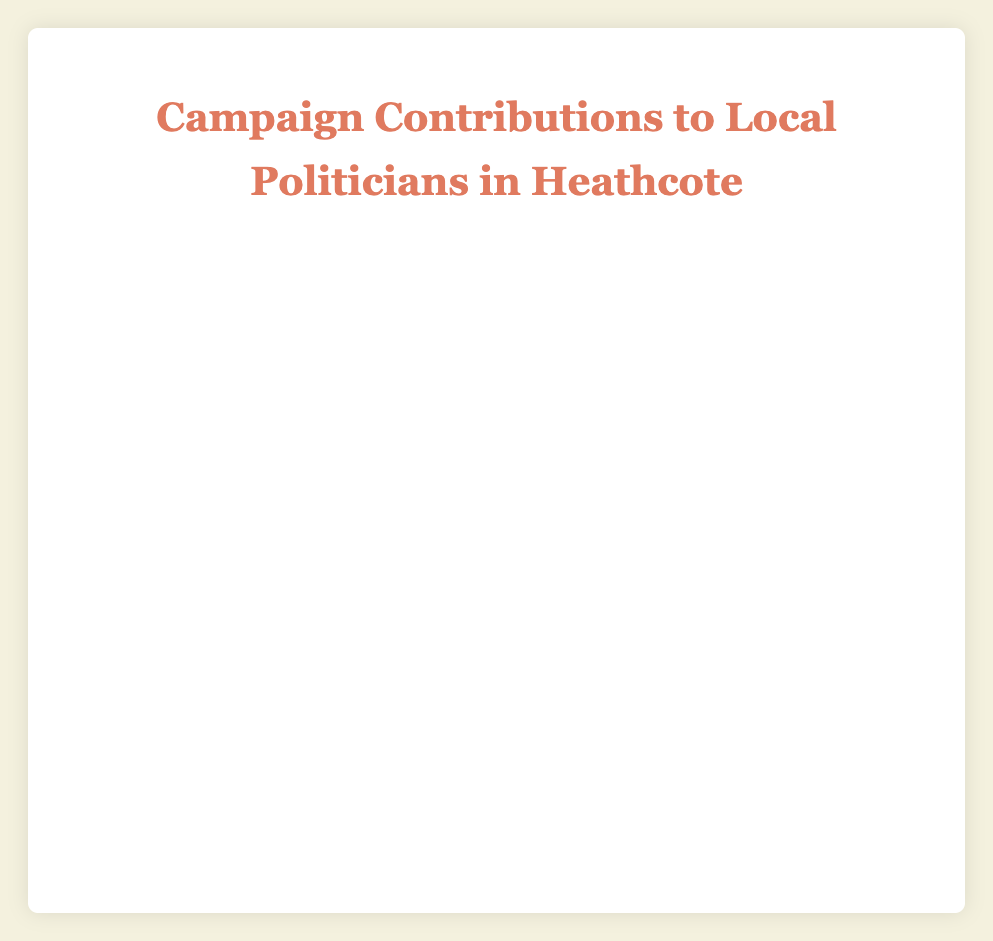Which politician received the highest total campaign contributions in the 2020 election cycle? From the chart, adding up the contributions from Individual, PAC, and Corporate Donations for each politician in 2020: Jane Doe: 22000 + 7000 + 3000 = 32000; John Smith: 20000 + 8000 + 4000 = 32000; Alice Johnson: 14000 + 4000 + 2000 = 20000; Robert Brown: 12000 + 5000 + 1500 = 18500. Jane Doe and John Smith both received the highest total contributions of 32000.
Answer: Jane Doe and John Smith Which election cycle had more Individual Donations for Jane Doe? Refer to the individual segments for Jane Doe in both election cycles. In 2018, she received 15000 from Individual Donations; in 2020, she received 22000 from Individual Donations. Thus, individual donations were higher in the 2020 election cycle.
Answer: 2020 How much more PAC Donations did John Smith receive in 2020 compared to 2018? Subtract the PAC Donations in 2018 from those in 2020 for John Smith. 8000 (2020) - 3000 (2018) = 5000 more PAC Donations in 2020.
Answer: 5000 Which politician received the least amount of Corporate Donations in the 2018 election cycle? Compare the Corporate Donations for all politicians in 2018: Jane Doe: 2000; John Smith: 5000; Alice Johnson: 1000; Robert Brown: 1000. Alice Johnson and Robert Brown both received the least amount of Corporate Donations, 1000.
Answer: Alice Johnson and Robert Brown If you sum the PAC Donations for every politician in 2020, what is the total? Add the PAC Donations for all politicians in 2020: Jane Doe: 7000; John Smith: 8000; Alice Johnson: 4000; Robert Brown: 5000. 7000 + 8000 + 4000 + 5000 = 24000.
Answer: 24000 Which color represents the Corporate Donations in the chart? From the visual attributes of the chart, Corporate Donations are represented by the red color segment in each bar.
Answer: Red By how much did Alice Johnson's total contributions increase from 2018 to 2020? Calculate the total contributions for Alice Johnson in each cycle and find the difference. 2018: 10000 + 2000 + 1000 = 13000; 2020: 14000 + 4000 + 2000 = 20000. Difference: 20000 - 13000 = 7000.
Answer: 7000 Is there any politician whose PAC Donations exceeded their Individual Donations in any election cycle? Check the dataset for instances where PAC Donations are greater than Individual Donations. None of the politicians have PAC Donations larger than Individual Donations in any cycle.
Answer: No What is the percentage of PAC Donations out of the total contributions for Robert Brown in the 2020 election cycle? First, calculate the total contributions for Robert Brown in 2020: 12000 + 5000 + 1500 = 18500. Then find the percentage of PAC Donations: (5000 / 18500) * 100% = approximately 27.03%.
Answer: 27.03% 